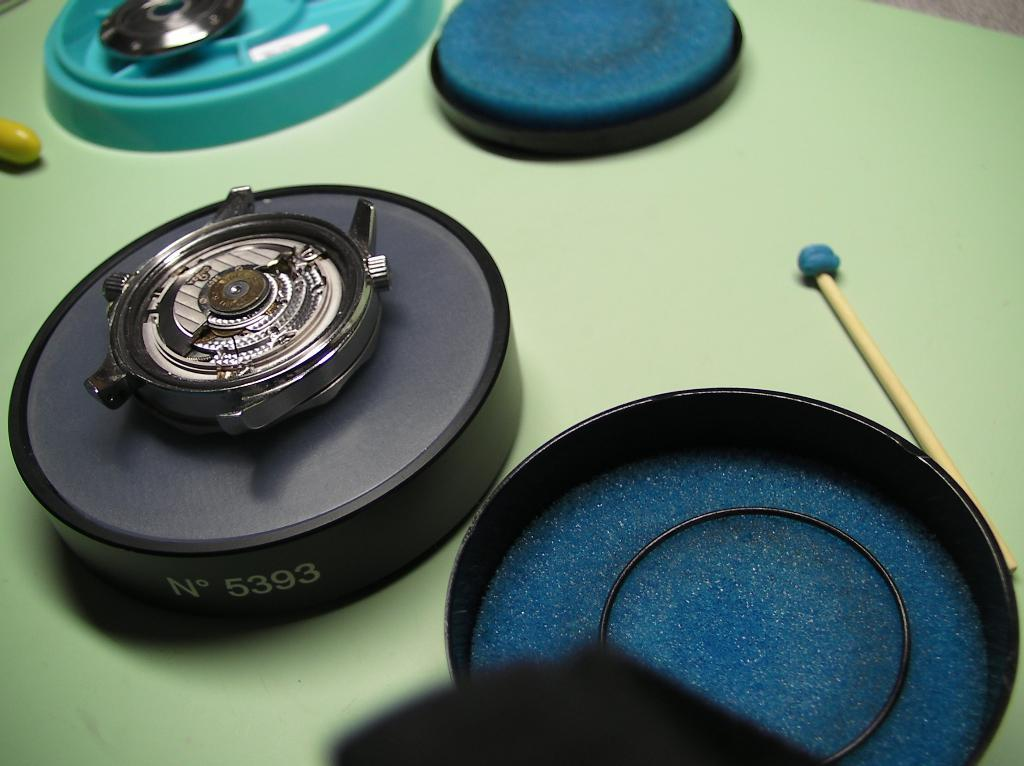<image>
Give a short and clear explanation of the subsequent image. a circle item with the letter N on it and 5393 